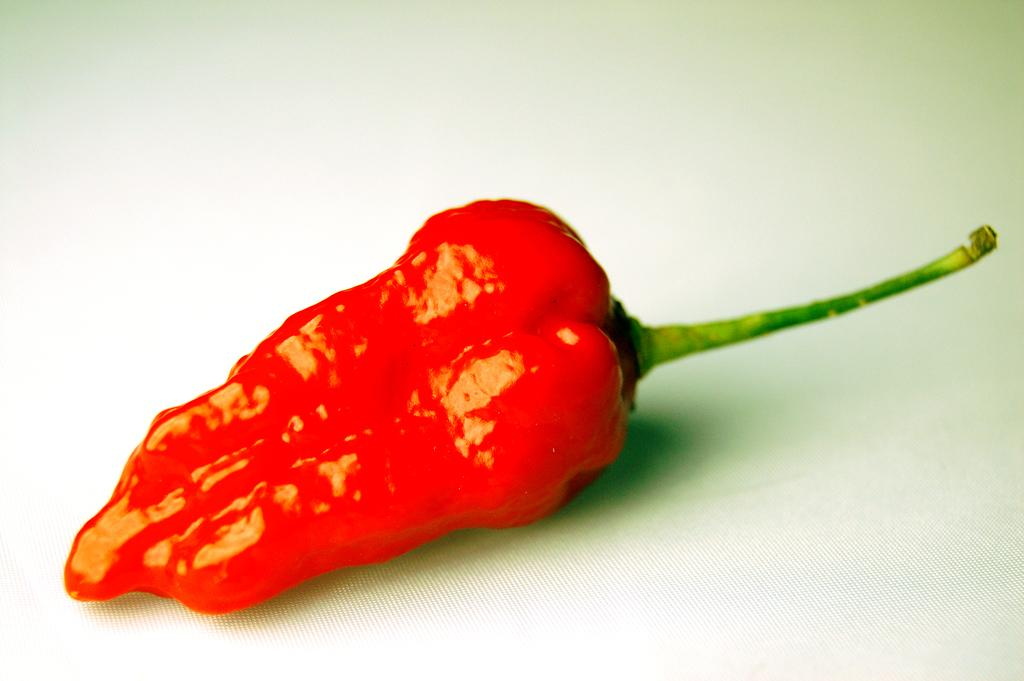What type of food is visible in the image? There are red chilies in the image. What color are the chilies? The red chilies are red. What is the color of the surface on which the chilies are placed? The red chilies are on a white surface. How many ladybugs can be seen crawling on the chilies in the image? There are no ladybugs present in the image; it only features red chilies on a white surface. 